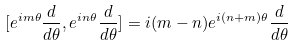Convert formula to latex. <formula><loc_0><loc_0><loc_500><loc_500>[ e ^ { i m \theta } \frac { d } { d \theta } , e ^ { i n \theta } \frac { d } { d \theta } ] = i ( m - n ) e ^ { i ( n + m ) \theta } \frac { d } { d \theta }</formula> 